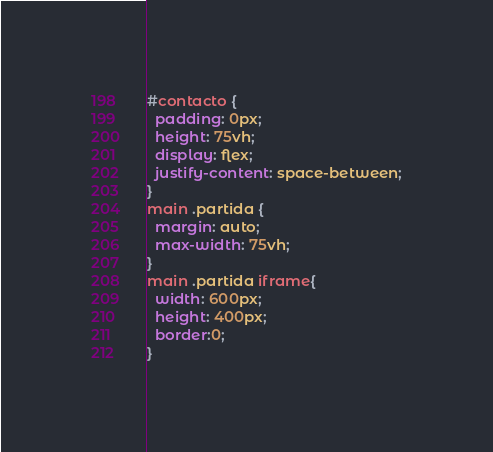Convert code to text. <code><loc_0><loc_0><loc_500><loc_500><_CSS_>#contacto {
  padding: 0px;
  height: 75vh;
  display: flex;
  justify-content: space-between;
}
main .partida {
  margin: auto;
  max-width: 75vh;
}
main .partida iframe{
  width: 600px;
  height: 400px;
  border:0;
}</code> 